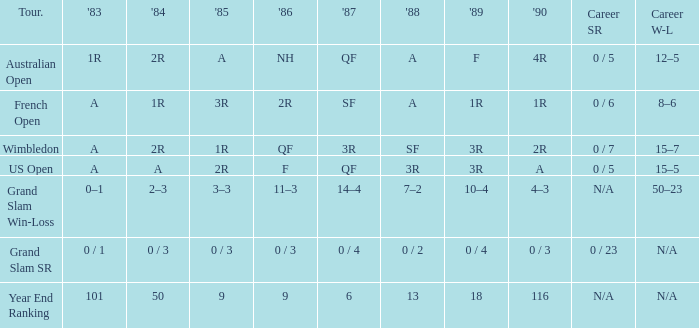With a 1986 of nh and a professional sr of 0 / 5, what are the outcomes in 1985? A. 